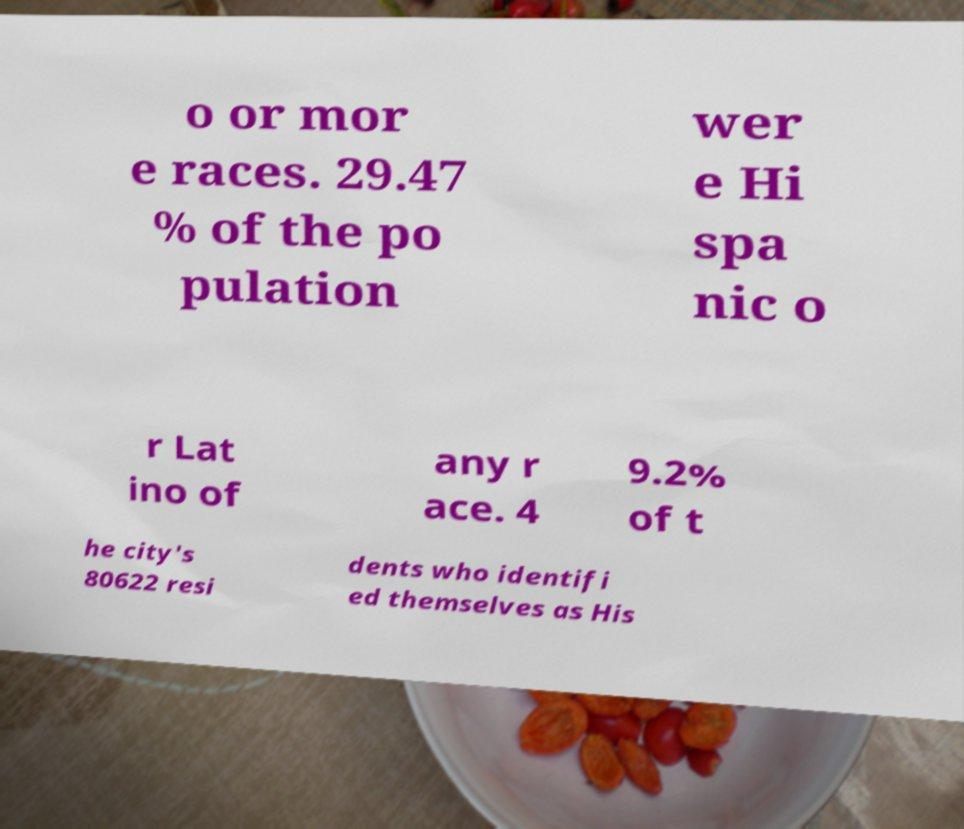Can you accurately transcribe the text from the provided image for me? o or mor e races. 29.47 % of the po pulation wer e Hi spa nic o r Lat ino of any r ace. 4 9.2% of t he city's 80622 resi dents who identifi ed themselves as His 